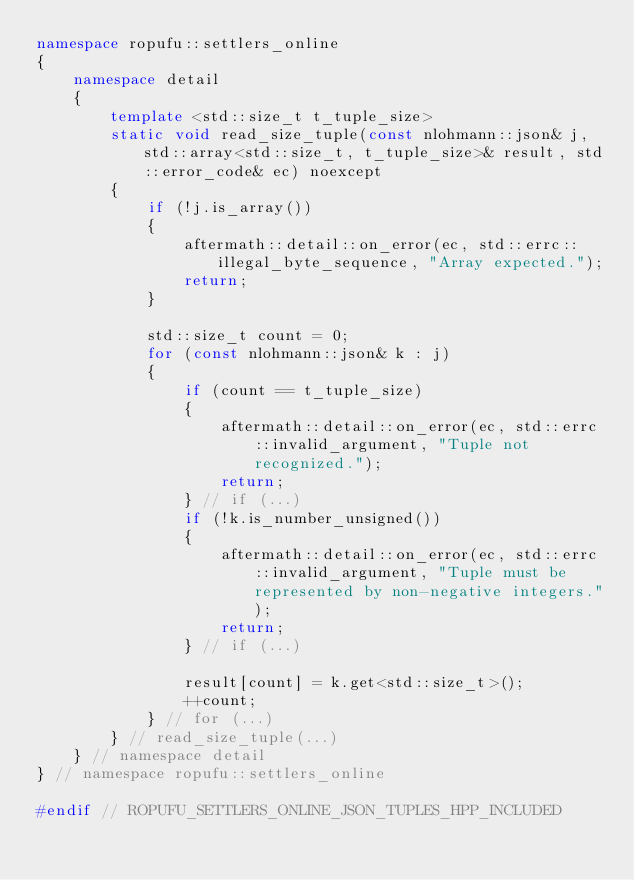Convert code to text. <code><loc_0><loc_0><loc_500><loc_500><_C++_>namespace ropufu::settlers_online
{
    namespace detail
    {
        template <std::size_t t_tuple_size>
        static void read_size_tuple(const nlohmann::json& j, std::array<std::size_t, t_tuple_size>& result, std::error_code& ec) noexcept
        {
            if (!j.is_array())
            {
                aftermath::detail::on_error(ec, std::errc::illegal_byte_sequence, "Array expected.");
                return;
            }
            
            std::size_t count = 0;
            for (const nlohmann::json& k : j)
            {
                if (count == t_tuple_size)
                {
                    aftermath::detail::on_error(ec, std::errc::invalid_argument, "Tuple not recognized.");
                    return;
                } // if (...)
                if (!k.is_number_unsigned())
                {
                    aftermath::detail::on_error(ec, std::errc::invalid_argument, "Tuple must be represented by non-negative integers.");
                    return;
                } // if (...)

                result[count] = k.get<std::size_t>();
                ++count;
            } // for (...)
        } // read_size_tuple(...)
    } // namespace detail
} // namespace ropufu::settlers_online

#endif // ROPUFU_SETTLERS_ONLINE_JSON_TUPLES_HPP_INCLUDED
</code> 